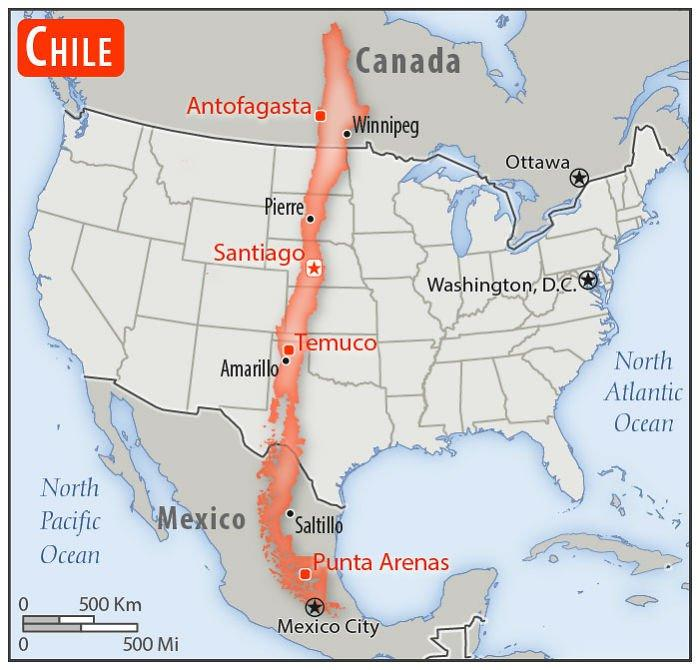Specify some key components in this picture. The place that is marked east of Santiago is Washington, D.C. The country whose name is written within the red rectangle is Chile. The number of countries depicted on the map is 4. The map depicts two oceans. Ottawa is the place located to the North of Washington, D.C. 